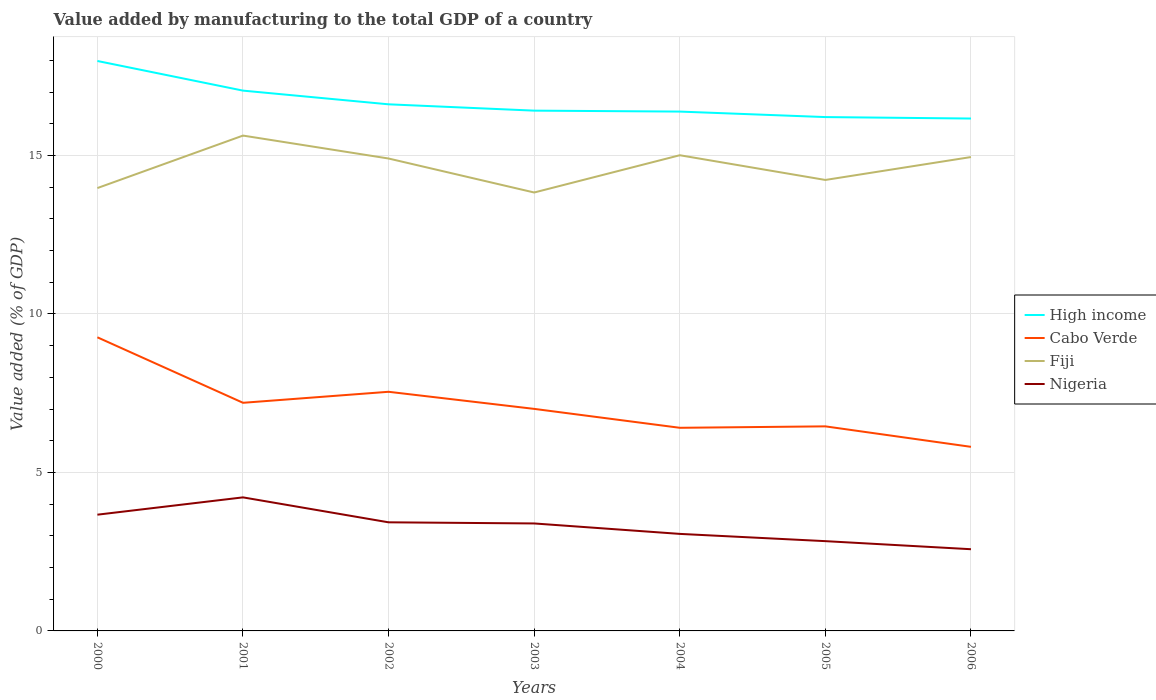Does the line corresponding to Nigeria intersect with the line corresponding to High income?
Give a very brief answer. No. Across all years, what is the maximum value added by manufacturing to the total GDP in Nigeria?
Your answer should be compact. 2.58. In which year was the value added by manufacturing to the total GDP in High income maximum?
Keep it short and to the point. 2006. What is the total value added by manufacturing to the total GDP in High income in the graph?
Offer a very short reply. 1.77. What is the difference between the highest and the second highest value added by manufacturing to the total GDP in Cabo Verde?
Your answer should be very brief. 3.46. What is the difference between the highest and the lowest value added by manufacturing to the total GDP in Fiji?
Provide a short and direct response. 4. How many lines are there?
Offer a terse response. 4. What is the difference between two consecutive major ticks on the Y-axis?
Ensure brevity in your answer.  5. Are the values on the major ticks of Y-axis written in scientific E-notation?
Ensure brevity in your answer.  No. Does the graph contain any zero values?
Give a very brief answer. No. Where does the legend appear in the graph?
Your answer should be very brief. Center right. What is the title of the graph?
Your response must be concise. Value added by manufacturing to the total GDP of a country. Does "Estonia" appear as one of the legend labels in the graph?
Your answer should be very brief. No. What is the label or title of the X-axis?
Provide a short and direct response. Years. What is the label or title of the Y-axis?
Provide a succinct answer. Value added (% of GDP). What is the Value added (% of GDP) in High income in 2000?
Your answer should be very brief. 17.98. What is the Value added (% of GDP) in Cabo Verde in 2000?
Make the answer very short. 9.26. What is the Value added (% of GDP) in Fiji in 2000?
Your response must be concise. 13.97. What is the Value added (% of GDP) in Nigeria in 2000?
Make the answer very short. 3.67. What is the Value added (% of GDP) in High income in 2001?
Keep it short and to the point. 17.05. What is the Value added (% of GDP) of Cabo Verde in 2001?
Your answer should be very brief. 7.2. What is the Value added (% of GDP) in Fiji in 2001?
Make the answer very short. 15.63. What is the Value added (% of GDP) of Nigeria in 2001?
Keep it short and to the point. 4.21. What is the Value added (% of GDP) of High income in 2002?
Offer a very short reply. 16.61. What is the Value added (% of GDP) of Cabo Verde in 2002?
Offer a terse response. 7.54. What is the Value added (% of GDP) in Fiji in 2002?
Your answer should be very brief. 14.9. What is the Value added (% of GDP) of Nigeria in 2002?
Give a very brief answer. 3.43. What is the Value added (% of GDP) in High income in 2003?
Make the answer very short. 16.41. What is the Value added (% of GDP) in Cabo Verde in 2003?
Provide a short and direct response. 7. What is the Value added (% of GDP) of Fiji in 2003?
Keep it short and to the point. 13.83. What is the Value added (% of GDP) in Nigeria in 2003?
Ensure brevity in your answer.  3.39. What is the Value added (% of GDP) of High income in 2004?
Ensure brevity in your answer.  16.38. What is the Value added (% of GDP) of Cabo Verde in 2004?
Provide a short and direct response. 6.41. What is the Value added (% of GDP) in Fiji in 2004?
Provide a short and direct response. 15.01. What is the Value added (% of GDP) in Nigeria in 2004?
Provide a succinct answer. 3.06. What is the Value added (% of GDP) of High income in 2005?
Your answer should be very brief. 16.21. What is the Value added (% of GDP) of Cabo Verde in 2005?
Ensure brevity in your answer.  6.45. What is the Value added (% of GDP) of Fiji in 2005?
Give a very brief answer. 14.23. What is the Value added (% of GDP) in Nigeria in 2005?
Your response must be concise. 2.83. What is the Value added (% of GDP) in High income in 2006?
Ensure brevity in your answer.  16.16. What is the Value added (% of GDP) of Cabo Verde in 2006?
Your answer should be compact. 5.81. What is the Value added (% of GDP) of Fiji in 2006?
Your answer should be very brief. 14.95. What is the Value added (% of GDP) of Nigeria in 2006?
Give a very brief answer. 2.58. Across all years, what is the maximum Value added (% of GDP) in High income?
Give a very brief answer. 17.98. Across all years, what is the maximum Value added (% of GDP) in Cabo Verde?
Offer a terse response. 9.26. Across all years, what is the maximum Value added (% of GDP) of Fiji?
Ensure brevity in your answer.  15.63. Across all years, what is the maximum Value added (% of GDP) in Nigeria?
Keep it short and to the point. 4.21. Across all years, what is the minimum Value added (% of GDP) in High income?
Your answer should be compact. 16.16. Across all years, what is the minimum Value added (% of GDP) of Cabo Verde?
Your answer should be compact. 5.81. Across all years, what is the minimum Value added (% of GDP) of Fiji?
Your answer should be compact. 13.83. Across all years, what is the minimum Value added (% of GDP) of Nigeria?
Ensure brevity in your answer.  2.58. What is the total Value added (% of GDP) of High income in the graph?
Offer a terse response. 116.81. What is the total Value added (% of GDP) of Cabo Verde in the graph?
Offer a very short reply. 49.68. What is the total Value added (% of GDP) of Fiji in the graph?
Keep it short and to the point. 102.52. What is the total Value added (% of GDP) of Nigeria in the graph?
Offer a very short reply. 23.17. What is the difference between the Value added (% of GDP) in High income in 2000 and that in 2001?
Keep it short and to the point. 0.93. What is the difference between the Value added (% of GDP) in Cabo Verde in 2000 and that in 2001?
Your answer should be compact. 2.07. What is the difference between the Value added (% of GDP) of Fiji in 2000 and that in 2001?
Provide a short and direct response. -1.66. What is the difference between the Value added (% of GDP) of Nigeria in 2000 and that in 2001?
Your answer should be compact. -0.55. What is the difference between the Value added (% of GDP) of High income in 2000 and that in 2002?
Make the answer very short. 1.37. What is the difference between the Value added (% of GDP) of Cabo Verde in 2000 and that in 2002?
Provide a succinct answer. 1.72. What is the difference between the Value added (% of GDP) in Fiji in 2000 and that in 2002?
Provide a short and direct response. -0.93. What is the difference between the Value added (% of GDP) of Nigeria in 2000 and that in 2002?
Provide a succinct answer. 0.24. What is the difference between the Value added (% of GDP) of High income in 2000 and that in 2003?
Make the answer very short. 1.57. What is the difference between the Value added (% of GDP) of Cabo Verde in 2000 and that in 2003?
Your response must be concise. 2.26. What is the difference between the Value added (% of GDP) of Fiji in 2000 and that in 2003?
Keep it short and to the point. 0.14. What is the difference between the Value added (% of GDP) in Nigeria in 2000 and that in 2003?
Keep it short and to the point. 0.28. What is the difference between the Value added (% of GDP) of High income in 2000 and that in 2004?
Offer a terse response. 1.6. What is the difference between the Value added (% of GDP) of Cabo Verde in 2000 and that in 2004?
Provide a succinct answer. 2.85. What is the difference between the Value added (% of GDP) of Fiji in 2000 and that in 2004?
Make the answer very short. -1.04. What is the difference between the Value added (% of GDP) in Nigeria in 2000 and that in 2004?
Ensure brevity in your answer.  0.61. What is the difference between the Value added (% of GDP) in High income in 2000 and that in 2005?
Your answer should be compact. 1.77. What is the difference between the Value added (% of GDP) in Cabo Verde in 2000 and that in 2005?
Your answer should be compact. 2.81. What is the difference between the Value added (% of GDP) of Fiji in 2000 and that in 2005?
Offer a very short reply. -0.26. What is the difference between the Value added (% of GDP) in Nigeria in 2000 and that in 2005?
Your response must be concise. 0.84. What is the difference between the Value added (% of GDP) in High income in 2000 and that in 2006?
Offer a terse response. 1.82. What is the difference between the Value added (% of GDP) of Cabo Verde in 2000 and that in 2006?
Provide a short and direct response. 3.46. What is the difference between the Value added (% of GDP) of Fiji in 2000 and that in 2006?
Provide a succinct answer. -0.98. What is the difference between the Value added (% of GDP) in Nigeria in 2000 and that in 2006?
Provide a succinct answer. 1.09. What is the difference between the Value added (% of GDP) in High income in 2001 and that in 2002?
Offer a very short reply. 0.43. What is the difference between the Value added (% of GDP) in Cabo Verde in 2001 and that in 2002?
Provide a short and direct response. -0.35. What is the difference between the Value added (% of GDP) of Fiji in 2001 and that in 2002?
Make the answer very short. 0.72. What is the difference between the Value added (% of GDP) in Nigeria in 2001 and that in 2002?
Your answer should be very brief. 0.79. What is the difference between the Value added (% of GDP) of High income in 2001 and that in 2003?
Ensure brevity in your answer.  0.63. What is the difference between the Value added (% of GDP) of Cabo Verde in 2001 and that in 2003?
Give a very brief answer. 0.19. What is the difference between the Value added (% of GDP) in Fiji in 2001 and that in 2003?
Provide a succinct answer. 1.8. What is the difference between the Value added (% of GDP) of Nigeria in 2001 and that in 2003?
Offer a very short reply. 0.82. What is the difference between the Value added (% of GDP) of High income in 2001 and that in 2004?
Your response must be concise. 0.66. What is the difference between the Value added (% of GDP) of Cabo Verde in 2001 and that in 2004?
Provide a short and direct response. 0.79. What is the difference between the Value added (% of GDP) of Fiji in 2001 and that in 2004?
Your answer should be compact. 0.62. What is the difference between the Value added (% of GDP) in Nigeria in 2001 and that in 2004?
Your answer should be very brief. 1.15. What is the difference between the Value added (% of GDP) of High income in 2001 and that in 2005?
Offer a terse response. 0.83. What is the difference between the Value added (% of GDP) in Cabo Verde in 2001 and that in 2005?
Give a very brief answer. 0.74. What is the difference between the Value added (% of GDP) in Fiji in 2001 and that in 2005?
Offer a very short reply. 1.4. What is the difference between the Value added (% of GDP) of Nigeria in 2001 and that in 2005?
Provide a short and direct response. 1.38. What is the difference between the Value added (% of GDP) of High income in 2001 and that in 2006?
Make the answer very short. 0.88. What is the difference between the Value added (% of GDP) in Cabo Verde in 2001 and that in 2006?
Give a very brief answer. 1.39. What is the difference between the Value added (% of GDP) in Fiji in 2001 and that in 2006?
Your answer should be very brief. 0.68. What is the difference between the Value added (% of GDP) of Nigeria in 2001 and that in 2006?
Provide a succinct answer. 1.64. What is the difference between the Value added (% of GDP) of High income in 2002 and that in 2003?
Provide a short and direct response. 0.2. What is the difference between the Value added (% of GDP) of Cabo Verde in 2002 and that in 2003?
Your answer should be compact. 0.54. What is the difference between the Value added (% of GDP) in Fiji in 2002 and that in 2003?
Your response must be concise. 1.07. What is the difference between the Value added (% of GDP) of Nigeria in 2002 and that in 2003?
Provide a short and direct response. 0.04. What is the difference between the Value added (% of GDP) in High income in 2002 and that in 2004?
Provide a short and direct response. 0.23. What is the difference between the Value added (% of GDP) in Cabo Verde in 2002 and that in 2004?
Make the answer very short. 1.14. What is the difference between the Value added (% of GDP) in Fiji in 2002 and that in 2004?
Give a very brief answer. -0.1. What is the difference between the Value added (% of GDP) in Nigeria in 2002 and that in 2004?
Offer a terse response. 0.36. What is the difference between the Value added (% of GDP) of High income in 2002 and that in 2005?
Offer a terse response. 0.4. What is the difference between the Value added (% of GDP) in Cabo Verde in 2002 and that in 2005?
Ensure brevity in your answer.  1.09. What is the difference between the Value added (% of GDP) in Fiji in 2002 and that in 2005?
Ensure brevity in your answer.  0.68. What is the difference between the Value added (% of GDP) of Nigeria in 2002 and that in 2005?
Keep it short and to the point. 0.59. What is the difference between the Value added (% of GDP) in High income in 2002 and that in 2006?
Your response must be concise. 0.45. What is the difference between the Value added (% of GDP) of Cabo Verde in 2002 and that in 2006?
Give a very brief answer. 1.74. What is the difference between the Value added (% of GDP) in Fiji in 2002 and that in 2006?
Offer a terse response. -0.05. What is the difference between the Value added (% of GDP) of Nigeria in 2002 and that in 2006?
Offer a terse response. 0.85. What is the difference between the Value added (% of GDP) of High income in 2003 and that in 2004?
Your response must be concise. 0.03. What is the difference between the Value added (% of GDP) of Cabo Verde in 2003 and that in 2004?
Provide a short and direct response. 0.6. What is the difference between the Value added (% of GDP) of Fiji in 2003 and that in 2004?
Provide a short and direct response. -1.18. What is the difference between the Value added (% of GDP) in Nigeria in 2003 and that in 2004?
Your answer should be very brief. 0.33. What is the difference between the Value added (% of GDP) in High income in 2003 and that in 2005?
Provide a succinct answer. 0.2. What is the difference between the Value added (% of GDP) of Cabo Verde in 2003 and that in 2005?
Give a very brief answer. 0.55. What is the difference between the Value added (% of GDP) of Fiji in 2003 and that in 2005?
Keep it short and to the point. -0.4. What is the difference between the Value added (% of GDP) of Nigeria in 2003 and that in 2005?
Your answer should be compact. 0.56. What is the difference between the Value added (% of GDP) of High income in 2003 and that in 2006?
Give a very brief answer. 0.25. What is the difference between the Value added (% of GDP) of Cabo Verde in 2003 and that in 2006?
Make the answer very short. 1.2. What is the difference between the Value added (% of GDP) of Fiji in 2003 and that in 2006?
Ensure brevity in your answer.  -1.12. What is the difference between the Value added (% of GDP) in Nigeria in 2003 and that in 2006?
Provide a succinct answer. 0.81. What is the difference between the Value added (% of GDP) of High income in 2004 and that in 2005?
Offer a terse response. 0.17. What is the difference between the Value added (% of GDP) of Cabo Verde in 2004 and that in 2005?
Offer a terse response. -0.05. What is the difference between the Value added (% of GDP) in Fiji in 2004 and that in 2005?
Offer a very short reply. 0.78. What is the difference between the Value added (% of GDP) in Nigeria in 2004 and that in 2005?
Your response must be concise. 0.23. What is the difference between the Value added (% of GDP) in High income in 2004 and that in 2006?
Offer a terse response. 0.22. What is the difference between the Value added (% of GDP) of Cabo Verde in 2004 and that in 2006?
Offer a terse response. 0.6. What is the difference between the Value added (% of GDP) of Fiji in 2004 and that in 2006?
Keep it short and to the point. 0.06. What is the difference between the Value added (% of GDP) in Nigeria in 2004 and that in 2006?
Offer a terse response. 0.48. What is the difference between the Value added (% of GDP) in High income in 2005 and that in 2006?
Your response must be concise. 0.05. What is the difference between the Value added (% of GDP) of Cabo Verde in 2005 and that in 2006?
Offer a terse response. 0.65. What is the difference between the Value added (% of GDP) of Fiji in 2005 and that in 2006?
Provide a short and direct response. -0.72. What is the difference between the Value added (% of GDP) in Nigeria in 2005 and that in 2006?
Your response must be concise. 0.25. What is the difference between the Value added (% of GDP) in High income in 2000 and the Value added (% of GDP) in Cabo Verde in 2001?
Keep it short and to the point. 10.78. What is the difference between the Value added (% of GDP) in High income in 2000 and the Value added (% of GDP) in Fiji in 2001?
Your response must be concise. 2.35. What is the difference between the Value added (% of GDP) of High income in 2000 and the Value added (% of GDP) of Nigeria in 2001?
Offer a very short reply. 13.77. What is the difference between the Value added (% of GDP) in Cabo Verde in 2000 and the Value added (% of GDP) in Fiji in 2001?
Provide a short and direct response. -6.36. What is the difference between the Value added (% of GDP) in Cabo Verde in 2000 and the Value added (% of GDP) in Nigeria in 2001?
Your answer should be compact. 5.05. What is the difference between the Value added (% of GDP) of Fiji in 2000 and the Value added (% of GDP) of Nigeria in 2001?
Your answer should be very brief. 9.76. What is the difference between the Value added (% of GDP) in High income in 2000 and the Value added (% of GDP) in Cabo Verde in 2002?
Ensure brevity in your answer.  10.44. What is the difference between the Value added (% of GDP) of High income in 2000 and the Value added (% of GDP) of Fiji in 2002?
Your response must be concise. 3.08. What is the difference between the Value added (% of GDP) in High income in 2000 and the Value added (% of GDP) in Nigeria in 2002?
Make the answer very short. 14.55. What is the difference between the Value added (% of GDP) in Cabo Verde in 2000 and the Value added (% of GDP) in Fiji in 2002?
Your answer should be compact. -5.64. What is the difference between the Value added (% of GDP) of Cabo Verde in 2000 and the Value added (% of GDP) of Nigeria in 2002?
Your response must be concise. 5.84. What is the difference between the Value added (% of GDP) in Fiji in 2000 and the Value added (% of GDP) in Nigeria in 2002?
Give a very brief answer. 10.55. What is the difference between the Value added (% of GDP) in High income in 2000 and the Value added (% of GDP) in Cabo Verde in 2003?
Make the answer very short. 10.98. What is the difference between the Value added (% of GDP) of High income in 2000 and the Value added (% of GDP) of Fiji in 2003?
Provide a short and direct response. 4.15. What is the difference between the Value added (% of GDP) in High income in 2000 and the Value added (% of GDP) in Nigeria in 2003?
Make the answer very short. 14.59. What is the difference between the Value added (% of GDP) of Cabo Verde in 2000 and the Value added (% of GDP) of Fiji in 2003?
Your answer should be very brief. -4.57. What is the difference between the Value added (% of GDP) in Cabo Verde in 2000 and the Value added (% of GDP) in Nigeria in 2003?
Your response must be concise. 5.87. What is the difference between the Value added (% of GDP) in Fiji in 2000 and the Value added (% of GDP) in Nigeria in 2003?
Your answer should be very brief. 10.58. What is the difference between the Value added (% of GDP) of High income in 2000 and the Value added (% of GDP) of Cabo Verde in 2004?
Provide a short and direct response. 11.57. What is the difference between the Value added (% of GDP) of High income in 2000 and the Value added (% of GDP) of Fiji in 2004?
Your answer should be very brief. 2.97. What is the difference between the Value added (% of GDP) of High income in 2000 and the Value added (% of GDP) of Nigeria in 2004?
Provide a succinct answer. 14.92. What is the difference between the Value added (% of GDP) of Cabo Verde in 2000 and the Value added (% of GDP) of Fiji in 2004?
Your answer should be very brief. -5.74. What is the difference between the Value added (% of GDP) in Cabo Verde in 2000 and the Value added (% of GDP) in Nigeria in 2004?
Provide a succinct answer. 6.2. What is the difference between the Value added (% of GDP) of Fiji in 2000 and the Value added (% of GDP) of Nigeria in 2004?
Your response must be concise. 10.91. What is the difference between the Value added (% of GDP) in High income in 2000 and the Value added (% of GDP) in Cabo Verde in 2005?
Your response must be concise. 11.53. What is the difference between the Value added (% of GDP) in High income in 2000 and the Value added (% of GDP) in Fiji in 2005?
Provide a short and direct response. 3.75. What is the difference between the Value added (% of GDP) in High income in 2000 and the Value added (% of GDP) in Nigeria in 2005?
Ensure brevity in your answer.  15.15. What is the difference between the Value added (% of GDP) in Cabo Verde in 2000 and the Value added (% of GDP) in Fiji in 2005?
Ensure brevity in your answer.  -4.96. What is the difference between the Value added (% of GDP) in Cabo Verde in 2000 and the Value added (% of GDP) in Nigeria in 2005?
Your response must be concise. 6.43. What is the difference between the Value added (% of GDP) of Fiji in 2000 and the Value added (% of GDP) of Nigeria in 2005?
Offer a terse response. 11.14. What is the difference between the Value added (% of GDP) of High income in 2000 and the Value added (% of GDP) of Cabo Verde in 2006?
Give a very brief answer. 12.17. What is the difference between the Value added (% of GDP) in High income in 2000 and the Value added (% of GDP) in Fiji in 2006?
Keep it short and to the point. 3.03. What is the difference between the Value added (% of GDP) of High income in 2000 and the Value added (% of GDP) of Nigeria in 2006?
Ensure brevity in your answer.  15.4. What is the difference between the Value added (% of GDP) of Cabo Verde in 2000 and the Value added (% of GDP) of Fiji in 2006?
Your answer should be very brief. -5.69. What is the difference between the Value added (% of GDP) of Cabo Verde in 2000 and the Value added (% of GDP) of Nigeria in 2006?
Make the answer very short. 6.69. What is the difference between the Value added (% of GDP) in Fiji in 2000 and the Value added (% of GDP) in Nigeria in 2006?
Provide a succinct answer. 11.39. What is the difference between the Value added (% of GDP) in High income in 2001 and the Value added (% of GDP) in Cabo Verde in 2002?
Keep it short and to the point. 9.5. What is the difference between the Value added (% of GDP) in High income in 2001 and the Value added (% of GDP) in Fiji in 2002?
Your response must be concise. 2.14. What is the difference between the Value added (% of GDP) in High income in 2001 and the Value added (% of GDP) in Nigeria in 2002?
Your response must be concise. 13.62. What is the difference between the Value added (% of GDP) in Cabo Verde in 2001 and the Value added (% of GDP) in Fiji in 2002?
Your answer should be compact. -7.71. What is the difference between the Value added (% of GDP) in Cabo Verde in 2001 and the Value added (% of GDP) in Nigeria in 2002?
Provide a succinct answer. 3.77. What is the difference between the Value added (% of GDP) of Fiji in 2001 and the Value added (% of GDP) of Nigeria in 2002?
Provide a succinct answer. 12.2. What is the difference between the Value added (% of GDP) in High income in 2001 and the Value added (% of GDP) in Cabo Verde in 2003?
Provide a succinct answer. 10.04. What is the difference between the Value added (% of GDP) in High income in 2001 and the Value added (% of GDP) in Fiji in 2003?
Your answer should be compact. 3.21. What is the difference between the Value added (% of GDP) in High income in 2001 and the Value added (% of GDP) in Nigeria in 2003?
Offer a very short reply. 13.65. What is the difference between the Value added (% of GDP) in Cabo Verde in 2001 and the Value added (% of GDP) in Fiji in 2003?
Offer a very short reply. -6.63. What is the difference between the Value added (% of GDP) of Cabo Verde in 2001 and the Value added (% of GDP) of Nigeria in 2003?
Provide a succinct answer. 3.81. What is the difference between the Value added (% of GDP) of Fiji in 2001 and the Value added (% of GDP) of Nigeria in 2003?
Provide a succinct answer. 12.24. What is the difference between the Value added (% of GDP) of High income in 2001 and the Value added (% of GDP) of Cabo Verde in 2004?
Offer a terse response. 10.64. What is the difference between the Value added (% of GDP) of High income in 2001 and the Value added (% of GDP) of Fiji in 2004?
Give a very brief answer. 2.04. What is the difference between the Value added (% of GDP) in High income in 2001 and the Value added (% of GDP) in Nigeria in 2004?
Your answer should be compact. 13.98. What is the difference between the Value added (% of GDP) of Cabo Verde in 2001 and the Value added (% of GDP) of Fiji in 2004?
Your response must be concise. -7.81. What is the difference between the Value added (% of GDP) of Cabo Verde in 2001 and the Value added (% of GDP) of Nigeria in 2004?
Your answer should be very brief. 4.14. What is the difference between the Value added (% of GDP) of Fiji in 2001 and the Value added (% of GDP) of Nigeria in 2004?
Make the answer very short. 12.57. What is the difference between the Value added (% of GDP) of High income in 2001 and the Value added (% of GDP) of Cabo Verde in 2005?
Your answer should be very brief. 10.59. What is the difference between the Value added (% of GDP) in High income in 2001 and the Value added (% of GDP) in Fiji in 2005?
Make the answer very short. 2.82. What is the difference between the Value added (% of GDP) in High income in 2001 and the Value added (% of GDP) in Nigeria in 2005?
Offer a very short reply. 14.21. What is the difference between the Value added (% of GDP) of Cabo Verde in 2001 and the Value added (% of GDP) of Fiji in 2005?
Ensure brevity in your answer.  -7.03. What is the difference between the Value added (% of GDP) of Cabo Verde in 2001 and the Value added (% of GDP) of Nigeria in 2005?
Make the answer very short. 4.36. What is the difference between the Value added (% of GDP) of Fiji in 2001 and the Value added (% of GDP) of Nigeria in 2005?
Ensure brevity in your answer.  12.79. What is the difference between the Value added (% of GDP) of High income in 2001 and the Value added (% of GDP) of Cabo Verde in 2006?
Offer a terse response. 11.24. What is the difference between the Value added (% of GDP) of High income in 2001 and the Value added (% of GDP) of Fiji in 2006?
Offer a very short reply. 2.1. What is the difference between the Value added (% of GDP) of High income in 2001 and the Value added (% of GDP) of Nigeria in 2006?
Provide a short and direct response. 14.47. What is the difference between the Value added (% of GDP) in Cabo Verde in 2001 and the Value added (% of GDP) in Fiji in 2006?
Make the answer very short. -7.75. What is the difference between the Value added (% of GDP) in Cabo Verde in 2001 and the Value added (% of GDP) in Nigeria in 2006?
Provide a short and direct response. 4.62. What is the difference between the Value added (% of GDP) of Fiji in 2001 and the Value added (% of GDP) of Nigeria in 2006?
Keep it short and to the point. 13.05. What is the difference between the Value added (% of GDP) in High income in 2002 and the Value added (% of GDP) in Cabo Verde in 2003?
Offer a very short reply. 9.61. What is the difference between the Value added (% of GDP) of High income in 2002 and the Value added (% of GDP) of Fiji in 2003?
Give a very brief answer. 2.78. What is the difference between the Value added (% of GDP) in High income in 2002 and the Value added (% of GDP) in Nigeria in 2003?
Make the answer very short. 13.22. What is the difference between the Value added (% of GDP) in Cabo Verde in 2002 and the Value added (% of GDP) in Fiji in 2003?
Your answer should be compact. -6.29. What is the difference between the Value added (% of GDP) in Cabo Verde in 2002 and the Value added (% of GDP) in Nigeria in 2003?
Offer a very short reply. 4.15. What is the difference between the Value added (% of GDP) in Fiji in 2002 and the Value added (% of GDP) in Nigeria in 2003?
Make the answer very short. 11.51. What is the difference between the Value added (% of GDP) of High income in 2002 and the Value added (% of GDP) of Cabo Verde in 2004?
Your answer should be compact. 10.2. What is the difference between the Value added (% of GDP) in High income in 2002 and the Value added (% of GDP) in Fiji in 2004?
Keep it short and to the point. 1.61. What is the difference between the Value added (% of GDP) of High income in 2002 and the Value added (% of GDP) of Nigeria in 2004?
Provide a short and direct response. 13.55. What is the difference between the Value added (% of GDP) of Cabo Verde in 2002 and the Value added (% of GDP) of Fiji in 2004?
Your answer should be compact. -7.46. What is the difference between the Value added (% of GDP) of Cabo Verde in 2002 and the Value added (% of GDP) of Nigeria in 2004?
Your answer should be compact. 4.48. What is the difference between the Value added (% of GDP) of Fiji in 2002 and the Value added (% of GDP) of Nigeria in 2004?
Make the answer very short. 11.84. What is the difference between the Value added (% of GDP) in High income in 2002 and the Value added (% of GDP) in Cabo Verde in 2005?
Offer a very short reply. 10.16. What is the difference between the Value added (% of GDP) of High income in 2002 and the Value added (% of GDP) of Fiji in 2005?
Keep it short and to the point. 2.39. What is the difference between the Value added (% of GDP) in High income in 2002 and the Value added (% of GDP) in Nigeria in 2005?
Offer a terse response. 13.78. What is the difference between the Value added (% of GDP) in Cabo Verde in 2002 and the Value added (% of GDP) in Fiji in 2005?
Keep it short and to the point. -6.68. What is the difference between the Value added (% of GDP) of Cabo Verde in 2002 and the Value added (% of GDP) of Nigeria in 2005?
Provide a short and direct response. 4.71. What is the difference between the Value added (% of GDP) in Fiji in 2002 and the Value added (% of GDP) in Nigeria in 2005?
Offer a very short reply. 12.07. What is the difference between the Value added (% of GDP) in High income in 2002 and the Value added (% of GDP) in Cabo Verde in 2006?
Provide a succinct answer. 10.81. What is the difference between the Value added (% of GDP) of High income in 2002 and the Value added (% of GDP) of Fiji in 2006?
Your response must be concise. 1.66. What is the difference between the Value added (% of GDP) of High income in 2002 and the Value added (% of GDP) of Nigeria in 2006?
Provide a short and direct response. 14.04. What is the difference between the Value added (% of GDP) of Cabo Verde in 2002 and the Value added (% of GDP) of Fiji in 2006?
Provide a succinct answer. -7.41. What is the difference between the Value added (% of GDP) in Cabo Verde in 2002 and the Value added (% of GDP) in Nigeria in 2006?
Your response must be concise. 4.97. What is the difference between the Value added (% of GDP) in Fiji in 2002 and the Value added (% of GDP) in Nigeria in 2006?
Your response must be concise. 12.33. What is the difference between the Value added (% of GDP) in High income in 2003 and the Value added (% of GDP) in Cabo Verde in 2004?
Provide a succinct answer. 10.01. What is the difference between the Value added (% of GDP) of High income in 2003 and the Value added (% of GDP) of Fiji in 2004?
Provide a succinct answer. 1.41. What is the difference between the Value added (% of GDP) in High income in 2003 and the Value added (% of GDP) in Nigeria in 2004?
Keep it short and to the point. 13.35. What is the difference between the Value added (% of GDP) of Cabo Verde in 2003 and the Value added (% of GDP) of Fiji in 2004?
Provide a succinct answer. -8. What is the difference between the Value added (% of GDP) of Cabo Verde in 2003 and the Value added (% of GDP) of Nigeria in 2004?
Ensure brevity in your answer.  3.94. What is the difference between the Value added (% of GDP) in Fiji in 2003 and the Value added (% of GDP) in Nigeria in 2004?
Provide a short and direct response. 10.77. What is the difference between the Value added (% of GDP) in High income in 2003 and the Value added (% of GDP) in Cabo Verde in 2005?
Provide a succinct answer. 9.96. What is the difference between the Value added (% of GDP) of High income in 2003 and the Value added (% of GDP) of Fiji in 2005?
Keep it short and to the point. 2.19. What is the difference between the Value added (% of GDP) of High income in 2003 and the Value added (% of GDP) of Nigeria in 2005?
Offer a very short reply. 13.58. What is the difference between the Value added (% of GDP) in Cabo Verde in 2003 and the Value added (% of GDP) in Fiji in 2005?
Give a very brief answer. -7.22. What is the difference between the Value added (% of GDP) in Cabo Verde in 2003 and the Value added (% of GDP) in Nigeria in 2005?
Offer a terse response. 4.17. What is the difference between the Value added (% of GDP) in Fiji in 2003 and the Value added (% of GDP) in Nigeria in 2005?
Offer a terse response. 11. What is the difference between the Value added (% of GDP) of High income in 2003 and the Value added (% of GDP) of Cabo Verde in 2006?
Offer a very short reply. 10.61. What is the difference between the Value added (% of GDP) of High income in 2003 and the Value added (% of GDP) of Fiji in 2006?
Your response must be concise. 1.46. What is the difference between the Value added (% of GDP) of High income in 2003 and the Value added (% of GDP) of Nigeria in 2006?
Your response must be concise. 13.84. What is the difference between the Value added (% of GDP) of Cabo Verde in 2003 and the Value added (% of GDP) of Fiji in 2006?
Provide a short and direct response. -7.94. What is the difference between the Value added (% of GDP) in Cabo Verde in 2003 and the Value added (% of GDP) in Nigeria in 2006?
Offer a terse response. 4.43. What is the difference between the Value added (% of GDP) of Fiji in 2003 and the Value added (% of GDP) of Nigeria in 2006?
Give a very brief answer. 11.25. What is the difference between the Value added (% of GDP) of High income in 2004 and the Value added (% of GDP) of Cabo Verde in 2005?
Keep it short and to the point. 9.93. What is the difference between the Value added (% of GDP) of High income in 2004 and the Value added (% of GDP) of Fiji in 2005?
Provide a short and direct response. 2.16. What is the difference between the Value added (% of GDP) of High income in 2004 and the Value added (% of GDP) of Nigeria in 2005?
Ensure brevity in your answer.  13.55. What is the difference between the Value added (% of GDP) of Cabo Verde in 2004 and the Value added (% of GDP) of Fiji in 2005?
Keep it short and to the point. -7.82. What is the difference between the Value added (% of GDP) in Cabo Verde in 2004 and the Value added (% of GDP) in Nigeria in 2005?
Offer a terse response. 3.58. What is the difference between the Value added (% of GDP) in Fiji in 2004 and the Value added (% of GDP) in Nigeria in 2005?
Your answer should be very brief. 12.17. What is the difference between the Value added (% of GDP) in High income in 2004 and the Value added (% of GDP) in Cabo Verde in 2006?
Provide a short and direct response. 10.58. What is the difference between the Value added (% of GDP) of High income in 2004 and the Value added (% of GDP) of Fiji in 2006?
Provide a succinct answer. 1.43. What is the difference between the Value added (% of GDP) in High income in 2004 and the Value added (% of GDP) in Nigeria in 2006?
Ensure brevity in your answer.  13.81. What is the difference between the Value added (% of GDP) of Cabo Verde in 2004 and the Value added (% of GDP) of Fiji in 2006?
Your response must be concise. -8.54. What is the difference between the Value added (% of GDP) of Cabo Verde in 2004 and the Value added (% of GDP) of Nigeria in 2006?
Offer a very short reply. 3.83. What is the difference between the Value added (% of GDP) of Fiji in 2004 and the Value added (% of GDP) of Nigeria in 2006?
Keep it short and to the point. 12.43. What is the difference between the Value added (% of GDP) of High income in 2005 and the Value added (% of GDP) of Cabo Verde in 2006?
Offer a terse response. 10.4. What is the difference between the Value added (% of GDP) in High income in 2005 and the Value added (% of GDP) in Fiji in 2006?
Provide a short and direct response. 1.26. What is the difference between the Value added (% of GDP) in High income in 2005 and the Value added (% of GDP) in Nigeria in 2006?
Give a very brief answer. 13.63. What is the difference between the Value added (% of GDP) in Cabo Verde in 2005 and the Value added (% of GDP) in Fiji in 2006?
Make the answer very short. -8.5. What is the difference between the Value added (% of GDP) of Cabo Verde in 2005 and the Value added (% of GDP) of Nigeria in 2006?
Provide a short and direct response. 3.88. What is the difference between the Value added (% of GDP) in Fiji in 2005 and the Value added (% of GDP) in Nigeria in 2006?
Your answer should be compact. 11.65. What is the average Value added (% of GDP) of High income per year?
Offer a terse response. 16.69. What is the average Value added (% of GDP) of Cabo Verde per year?
Your response must be concise. 7.1. What is the average Value added (% of GDP) in Fiji per year?
Offer a terse response. 14.65. What is the average Value added (% of GDP) in Nigeria per year?
Ensure brevity in your answer.  3.31. In the year 2000, what is the difference between the Value added (% of GDP) of High income and Value added (% of GDP) of Cabo Verde?
Provide a short and direct response. 8.72. In the year 2000, what is the difference between the Value added (% of GDP) of High income and Value added (% of GDP) of Fiji?
Keep it short and to the point. 4.01. In the year 2000, what is the difference between the Value added (% of GDP) in High income and Value added (% of GDP) in Nigeria?
Your answer should be very brief. 14.31. In the year 2000, what is the difference between the Value added (% of GDP) of Cabo Verde and Value added (% of GDP) of Fiji?
Offer a terse response. -4.71. In the year 2000, what is the difference between the Value added (% of GDP) of Cabo Verde and Value added (% of GDP) of Nigeria?
Keep it short and to the point. 5.6. In the year 2000, what is the difference between the Value added (% of GDP) of Fiji and Value added (% of GDP) of Nigeria?
Your answer should be very brief. 10.3. In the year 2001, what is the difference between the Value added (% of GDP) of High income and Value added (% of GDP) of Cabo Verde?
Offer a very short reply. 9.85. In the year 2001, what is the difference between the Value added (% of GDP) of High income and Value added (% of GDP) of Fiji?
Your answer should be very brief. 1.42. In the year 2001, what is the difference between the Value added (% of GDP) in High income and Value added (% of GDP) in Nigeria?
Your answer should be compact. 12.83. In the year 2001, what is the difference between the Value added (% of GDP) of Cabo Verde and Value added (% of GDP) of Fiji?
Provide a succinct answer. -8.43. In the year 2001, what is the difference between the Value added (% of GDP) in Cabo Verde and Value added (% of GDP) in Nigeria?
Provide a succinct answer. 2.98. In the year 2001, what is the difference between the Value added (% of GDP) of Fiji and Value added (% of GDP) of Nigeria?
Keep it short and to the point. 11.41. In the year 2002, what is the difference between the Value added (% of GDP) in High income and Value added (% of GDP) in Cabo Verde?
Offer a very short reply. 9.07. In the year 2002, what is the difference between the Value added (% of GDP) of High income and Value added (% of GDP) of Fiji?
Your answer should be very brief. 1.71. In the year 2002, what is the difference between the Value added (% of GDP) in High income and Value added (% of GDP) in Nigeria?
Ensure brevity in your answer.  13.19. In the year 2002, what is the difference between the Value added (% of GDP) of Cabo Verde and Value added (% of GDP) of Fiji?
Provide a succinct answer. -7.36. In the year 2002, what is the difference between the Value added (% of GDP) of Cabo Verde and Value added (% of GDP) of Nigeria?
Your answer should be compact. 4.12. In the year 2002, what is the difference between the Value added (% of GDP) in Fiji and Value added (% of GDP) in Nigeria?
Make the answer very short. 11.48. In the year 2003, what is the difference between the Value added (% of GDP) in High income and Value added (% of GDP) in Cabo Verde?
Ensure brevity in your answer.  9.41. In the year 2003, what is the difference between the Value added (% of GDP) of High income and Value added (% of GDP) of Fiji?
Make the answer very short. 2.58. In the year 2003, what is the difference between the Value added (% of GDP) of High income and Value added (% of GDP) of Nigeria?
Make the answer very short. 13.02. In the year 2003, what is the difference between the Value added (% of GDP) in Cabo Verde and Value added (% of GDP) in Fiji?
Your response must be concise. -6.83. In the year 2003, what is the difference between the Value added (% of GDP) in Cabo Verde and Value added (% of GDP) in Nigeria?
Your answer should be very brief. 3.61. In the year 2003, what is the difference between the Value added (% of GDP) of Fiji and Value added (% of GDP) of Nigeria?
Your answer should be very brief. 10.44. In the year 2004, what is the difference between the Value added (% of GDP) of High income and Value added (% of GDP) of Cabo Verde?
Keep it short and to the point. 9.98. In the year 2004, what is the difference between the Value added (% of GDP) of High income and Value added (% of GDP) of Fiji?
Your answer should be compact. 1.38. In the year 2004, what is the difference between the Value added (% of GDP) of High income and Value added (% of GDP) of Nigeria?
Your response must be concise. 13.32. In the year 2004, what is the difference between the Value added (% of GDP) of Cabo Verde and Value added (% of GDP) of Fiji?
Provide a short and direct response. -8.6. In the year 2004, what is the difference between the Value added (% of GDP) in Cabo Verde and Value added (% of GDP) in Nigeria?
Provide a succinct answer. 3.35. In the year 2004, what is the difference between the Value added (% of GDP) of Fiji and Value added (% of GDP) of Nigeria?
Give a very brief answer. 11.95. In the year 2005, what is the difference between the Value added (% of GDP) in High income and Value added (% of GDP) in Cabo Verde?
Keep it short and to the point. 9.76. In the year 2005, what is the difference between the Value added (% of GDP) of High income and Value added (% of GDP) of Fiji?
Your answer should be very brief. 1.98. In the year 2005, what is the difference between the Value added (% of GDP) in High income and Value added (% of GDP) in Nigeria?
Your answer should be compact. 13.38. In the year 2005, what is the difference between the Value added (% of GDP) in Cabo Verde and Value added (% of GDP) in Fiji?
Provide a short and direct response. -7.77. In the year 2005, what is the difference between the Value added (% of GDP) in Cabo Verde and Value added (% of GDP) in Nigeria?
Offer a very short reply. 3.62. In the year 2005, what is the difference between the Value added (% of GDP) of Fiji and Value added (% of GDP) of Nigeria?
Provide a succinct answer. 11.39. In the year 2006, what is the difference between the Value added (% of GDP) in High income and Value added (% of GDP) in Cabo Verde?
Your answer should be compact. 10.36. In the year 2006, what is the difference between the Value added (% of GDP) in High income and Value added (% of GDP) in Fiji?
Keep it short and to the point. 1.22. In the year 2006, what is the difference between the Value added (% of GDP) in High income and Value added (% of GDP) in Nigeria?
Provide a short and direct response. 13.59. In the year 2006, what is the difference between the Value added (% of GDP) in Cabo Verde and Value added (% of GDP) in Fiji?
Your answer should be compact. -9.14. In the year 2006, what is the difference between the Value added (% of GDP) of Cabo Verde and Value added (% of GDP) of Nigeria?
Provide a succinct answer. 3.23. In the year 2006, what is the difference between the Value added (% of GDP) of Fiji and Value added (% of GDP) of Nigeria?
Your response must be concise. 12.37. What is the ratio of the Value added (% of GDP) in High income in 2000 to that in 2001?
Ensure brevity in your answer.  1.05. What is the ratio of the Value added (% of GDP) of Cabo Verde in 2000 to that in 2001?
Provide a short and direct response. 1.29. What is the ratio of the Value added (% of GDP) in Fiji in 2000 to that in 2001?
Make the answer very short. 0.89. What is the ratio of the Value added (% of GDP) in Nigeria in 2000 to that in 2001?
Make the answer very short. 0.87. What is the ratio of the Value added (% of GDP) of High income in 2000 to that in 2002?
Give a very brief answer. 1.08. What is the ratio of the Value added (% of GDP) of Cabo Verde in 2000 to that in 2002?
Offer a terse response. 1.23. What is the ratio of the Value added (% of GDP) of Nigeria in 2000 to that in 2002?
Offer a terse response. 1.07. What is the ratio of the Value added (% of GDP) in High income in 2000 to that in 2003?
Give a very brief answer. 1.1. What is the ratio of the Value added (% of GDP) of Cabo Verde in 2000 to that in 2003?
Provide a succinct answer. 1.32. What is the ratio of the Value added (% of GDP) of Nigeria in 2000 to that in 2003?
Your answer should be very brief. 1.08. What is the ratio of the Value added (% of GDP) in High income in 2000 to that in 2004?
Provide a succinct answer. 1.1. What is the ratio of the Value added (% of GDP) of Cabo Verde in 2000 to that in 2004?
Provide a succinct answer. 1.45. What is the ratio of the Value added (% of GDP) of Nigeria in 2000 to that in 2004?
Your answer should be very brief. 1.2. What is the ratio of the Value added (% of GDP) of High income in 2000 to that in 2005?
Offer a very short reply. 1.11. What is the ratio of the Value added (% of GDP) in Cabo Verde in 2000 to that in 2005?
Your answer should be very brief. 1.44. What is the ratio of the Value added (% of GDP) in Fiji in 2000 to that in 2005?
Your response must be concise. 0.98. What is the ratio of the Value added (% of GDP) in Nigeria in 2000 to that in 2005?
Your answer should be compact. 1.29. What is the ratio of the Value added (% of GDP) in High income in 2000 to that in 2006?
Give a very brief answer. 1.11. What is the ratio of the Value added (% of GDP) in Cabo Verde in 2000 to that in 2006?
Your answer should be compact. 1.59. What is the ratio of the Value added (% of GDP) of Fiji in 2000 to that in 2006?
Your answer should be compact. 0.93. What is the ratio of the Value added (% of GDP) of Nigeria in 2000 to that in 2006?
Offer a terse response. 1.42. What is the ratio of the Value added (% of GDP) in Cabo Verde in 2001 to that in 2002?
Offer a terse response. 0.95. What is the ratio of the Value added (% of GDP) of Fiji in 2001 to that in 2002?
Provide a succinct answer. 1.05. What is the ratio of the Value added (% of GDP) of Nigeria in 2001 to that in 2002?
Your answer should be very brief. 1.23. What is the ratio of the Value added (% of GDP) of High income in 2001 to that in 2003?
Provide a short and direct response. 1.04. What is the ratio of the Value added (% of GDP) of Cabo Verde in 2001 to that in 2003?
Provide a succinct answer. 1.03. What is the ratio of the Value added (% of GDP) of Fiji in 2001 to that in 2003?
Give a very brief answer. 1.13. What is the ratio of the Value added (% of GDP) in Nigeria in 2001 to that in 2003?
Provide a short and direct response. 1.24. What is the ratio of the Value added (% of GDP) in High income in 2001 to that in 2004?
Ensure brevity in your answer.  1.04. What is the ratio of the Value added (% of GDP) of Cabo Verde in 2001 to that in 2004?
Give a very brief answer. 1.12. What is the ratio of the Value added (% of GDP) of Fiji in 2001 to that in 2004?
Provide a short and direct response. 1.04. What is the ratio of the Value added (% of GDP) in Nigeria in 2001 to that in 2004?
Provide a short and direct response. 1.38. What is the ratio of the Value added (% of GDP) of High income in 2001 to that in 2005?
Keep it short and to the point. 1.05. What is the ratio of the Value added (% of GDP) in Cabo Verde in 2001 to that in 2005?
Make the answer very short. 1.12. What is the ratio of the Value added (% of GDP) in Fiji in 2001 to that in 2005?
Your response must be concise. 1.1. What is the ratio of the Value added (% of GDP) of Nigeria in 2001 to that in 2005?
Keep it short and to the point. 1.49. What is the ratio of the Value added (% of GDP) of High income in 2001 to that in 2006?
Offer a very short reply. 1.05. What is the ratio of the Value added (% of GDP) in Cabo Verde in 2001 to that in 2006?
Your response must be concise. 1.24. What is the ratio of the Value added (% of GDP) of Fiji in 2001 to that in 2006?
Ensure brevity in your answer.  1.05. What is the ratio of the Value added (% of GDP) of Nigeria in 2001 to that in 2006?
Provide a succinct answer. 1.63. What is the ratio of the Value added (% of GDP) of High income in 2002 to that in 2003?
Keep it short and to the point. 1.01. What is the ratio of the Value added (% of GDP) of Cabo Verde in 2002 to that in 2003?
Your answer should be very brief. 1.08. What is the ratio of the Value added (% of GDP) of Fiji in 2002 to that in 2003?
Your answer should be very brief. 1.08. What is the ratio of the Value added (% of GDP) in Nigeria in 2002 to that in 2003?
Ensure brevity in your answer.  1.01. What is the ratio of the Value added (% of GDP) of High income in 2002 to that in 2004?
Your answer should be compact. 1.01. What is the ratio of the Value added (% of GDP) in Cabo Verde in 2002 to that in 2004?
Your answer should be compact. 1.18. What is the ratio of the Value added (% of GDP) in Fiji in 2002 to that in 2004?
Offer a very short reply. 0.99. What is the ratio of the Value added (% of GDP) of Nigeria in 2002 to that in 2004?
Your response must be concise. 1.12. What is the ratio of the Value added (% of GDP) of High income in 2002 to that in 2005?
Ensure brevity in your answer.  1.02. What is the ratio of the Value added (% of GDP) in Cabo Verde in 2002 to that in 2005?
Provide a short and direct response. 1.17. What is the ratio of the Value added (% of GDP) of Fiji in 2002 to that in 2005?
Provide a short and direct response. 1.05. What is the ratio of the Value added (% of GDP) of Nigeria in 2002 to that in 2005?
Make the answer very short. 1.21. What is the ratio of the Value added (% of GDP) in High income in 2002 to that in 2006?
Make the answer very short. 1.03. What is the ratio of the Value added (% of GDP) in Cabo Verde in 2002 to that in 2006?
Provide a short and direct response. 1.3. What is the ratio of the Value added (% of GDP) in Nigeria in 2002 to that in 2006?
Make the answer very short. 1.33. What is the ratio of the Value added (% of GDP) in Cabo Verde in 2003 to that in 2004?
Provide a succinct answer. 1.09. What is the ratio of the Value added (% of GDP) in Fiji in 2003 to that in 2004?
Offer a terse response. 0.92. What is the ratio of the Value added (% of GDP) in Nigeria in 2003 to that in 2004?
Provide a short and direct response. 1.11. What is the ratio of the Value added (% of GDP) of High income in 2003 to that in 2005?
Give a very brief answer. 1.01. What is the ratio of the Value added (% of GDP) in Cabo Verde in 2003 to that in 2005?
Make the answer very short. 1.09. What is the ratio of the Value added (% of GDP) of Fiji in 2003 to that in 2005?
Offer a very short reply. 0.97. What is the ratio of the Value added (% of GDP) in Nigeria in 2003 to that in 2005?
Provide a succinct answer. 1.2. What is the ratio of the Value added (% of GDP) of High income in 2003 to that in 2006?
Offer a very short reply. 1.02. What is the ratio of the Value added (% of GDP) of Cabo Verde in 2003 to that in 2006?
Your response must be concise. 1.21. What is the ratio of the Value added (% of GDP) of Fiji in 2003 to that in 2006?
Your answer should be very brief. 0.93. What is the ratio of the Value added (% of GDP) of Nigeria in 2003 to that in 2006?
Your answer should be compact. 1.32. What is the ratio of the Value added (% of GDP) of High income in 2004 to that in 2005?
Your answer should be very brief. 1.01. What is the ratio of the Value added (% of GDP) in Fiji in 2004 to that in 2005?
Give a very brief answer. 1.05. What is the ratio of the Value added (% of GDP) of Nigeria in 2004 to that in 2005?
Keep it short and to the point. 1.08. What is the ratio of the Value added (% of GDP) of High income in 2004 to that in 2006?
Keep it short and to the point. 1.01. What is the ratio of the Value added (% of GDP) in Cabo Verde in 2004 to that in 2006?
Ensure brevity in your answer.  1.1. What is the ratio of the Value added (% of GDP) of Nigeria in 2004 to that in 2006?
Your response must be concise. 1.19. What is the ratio of the Value added (% of GDP) in High income in 2005 to that in 2006?
Make the answer very short. 1. What is the ratio of the Value added (% of GDP) of Cabo Verde in 2005 to that in 2006?
Your answer should be compact. 1.11. What is the ratio of the Value added (% of GDP) in Fiji in 2005 to that in 2006?
Give a very brief answer. 0.95. What is the ratio of the Value added (% of GDP) of Nigeria in 2005 to that in 2006?
Make the answer very short. 1.1. What is the difference between the highest and the second highest Value added (% of GDP) in High income?
Your answer should be compact. 0.93. What is the difference between the highest and the second highest Value added (% of GDP) in Cabo Verde?
Your response must be concise. 1.72. What is the difference between the highest and the second highest Value added (% of GDP) of Fiji?
Give a very brief answer. 0.62. What is the difference between the highest and the second highest Value added (% of GDP) of Nigeria?
Offer a very short reply. 0.55. What is the difference between the highest and the lowest Value added (% of GDP) of High income?
Give a very brief answer. 1.82. What is the difference between the highest and the lowest Value added (% of GDP) of Cabo Verde?
Offer a terse response. 3.46. What is the difference between the highest and the lowest Value added (% of GDP) in Fiji?
Ensure brevity in your answer.  1.8. What is the difference between the highest and the lowest Value added (% of GDP) of Nigeria?
Offer a terse response. 1.64. 